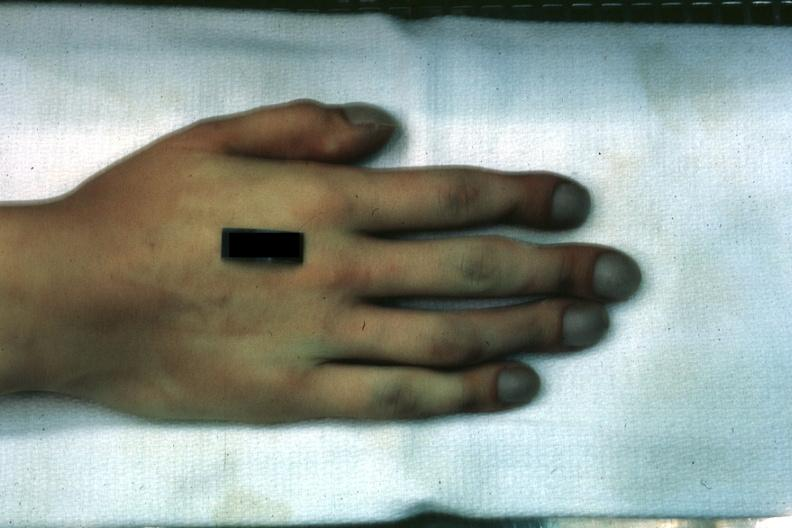re gangrene fingers present?
Answer the question using a single word or phrase. No 